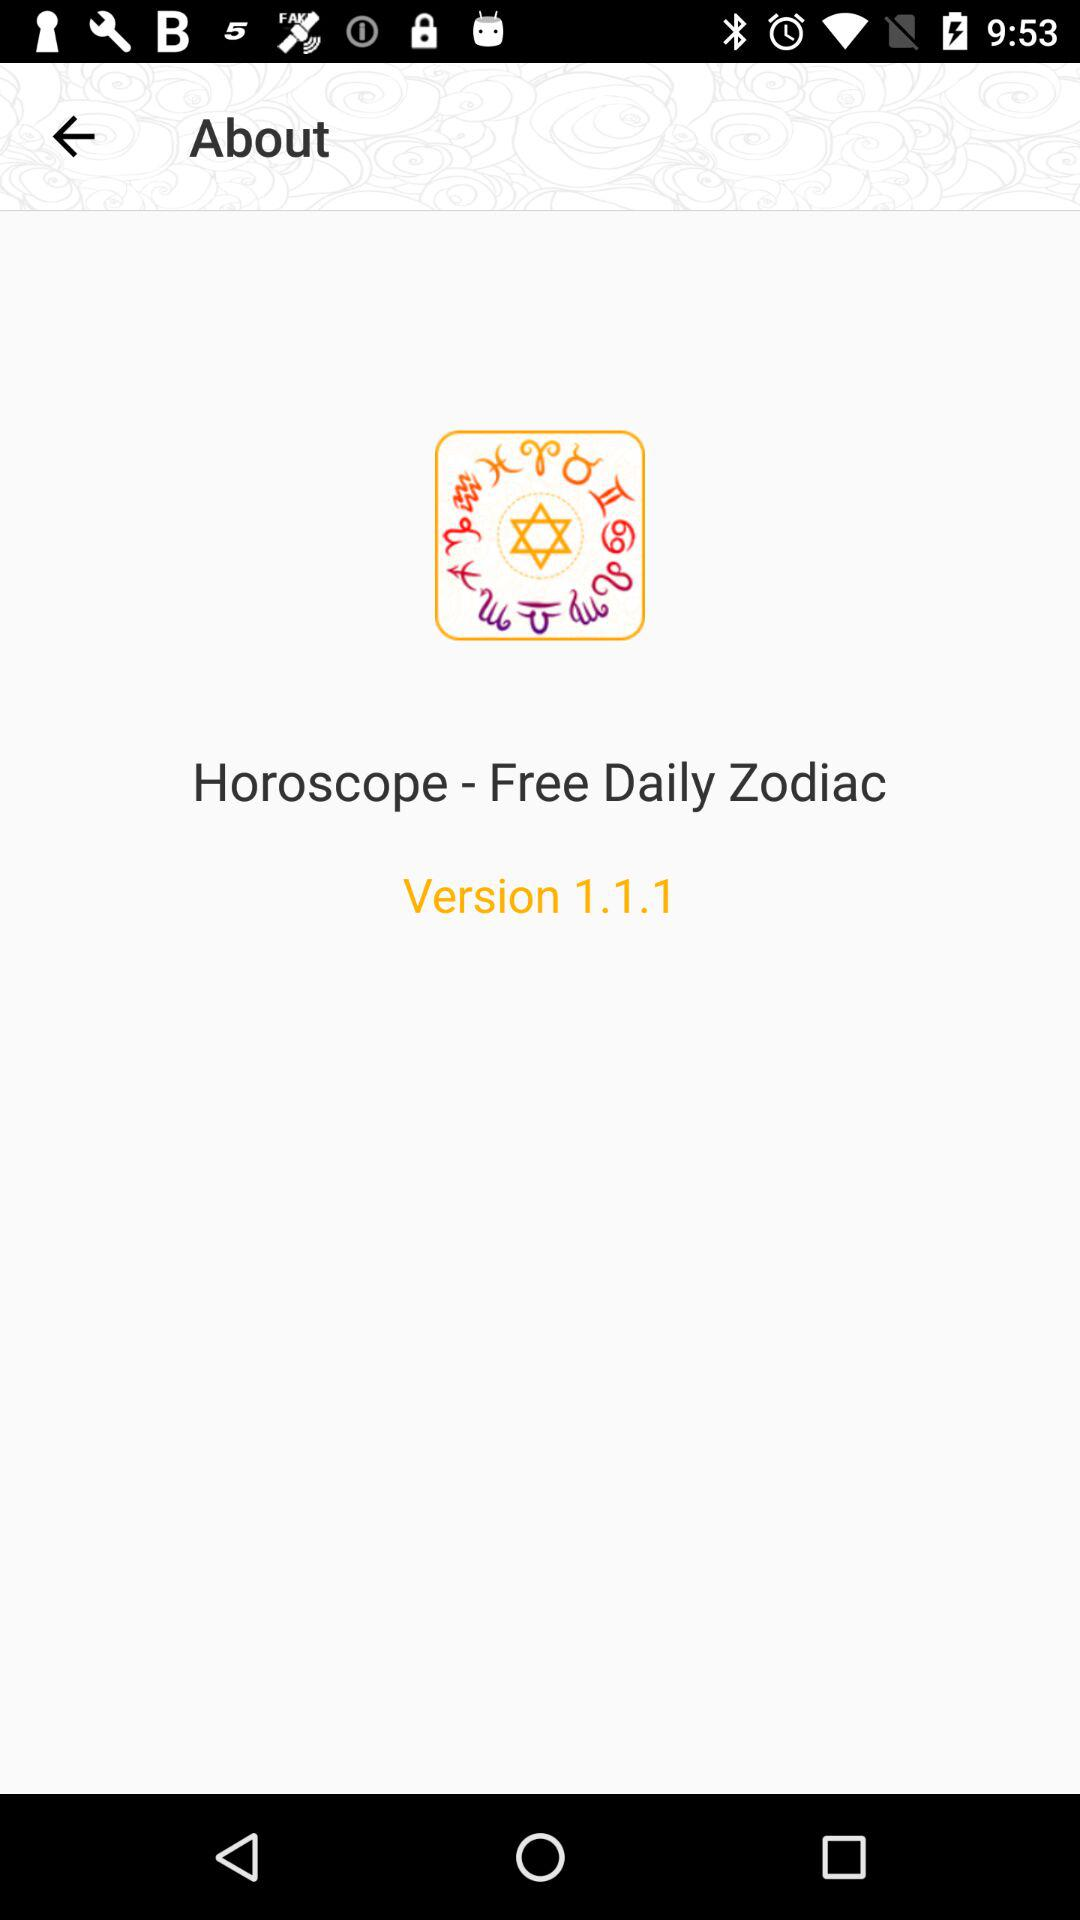What is the application name? The application name is "Horoscope - Free Daily Zodiac". 